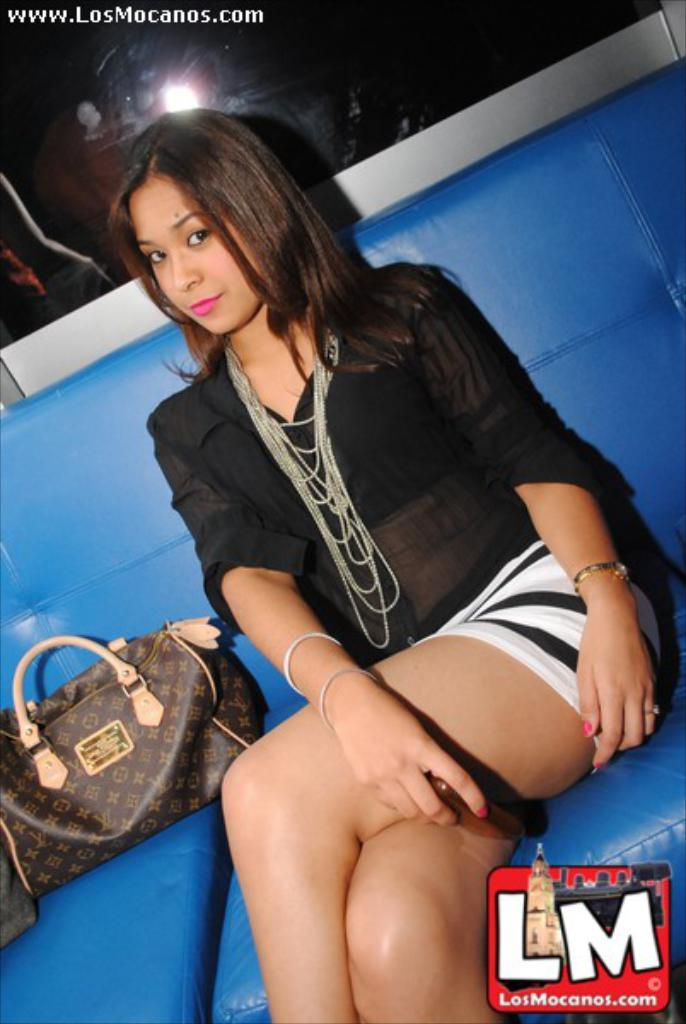What is the woman doing in the image? The woman is sitting on a couch in the image. What object is beside the woman? There is a handbag beside the woman. What color is the couch the woman is sitting on? The couch is blue in color. What island can be seen in the background of the image? There is no island visible in the image; it only shows a woman sitting on a blue couch with a handbag beside her. 